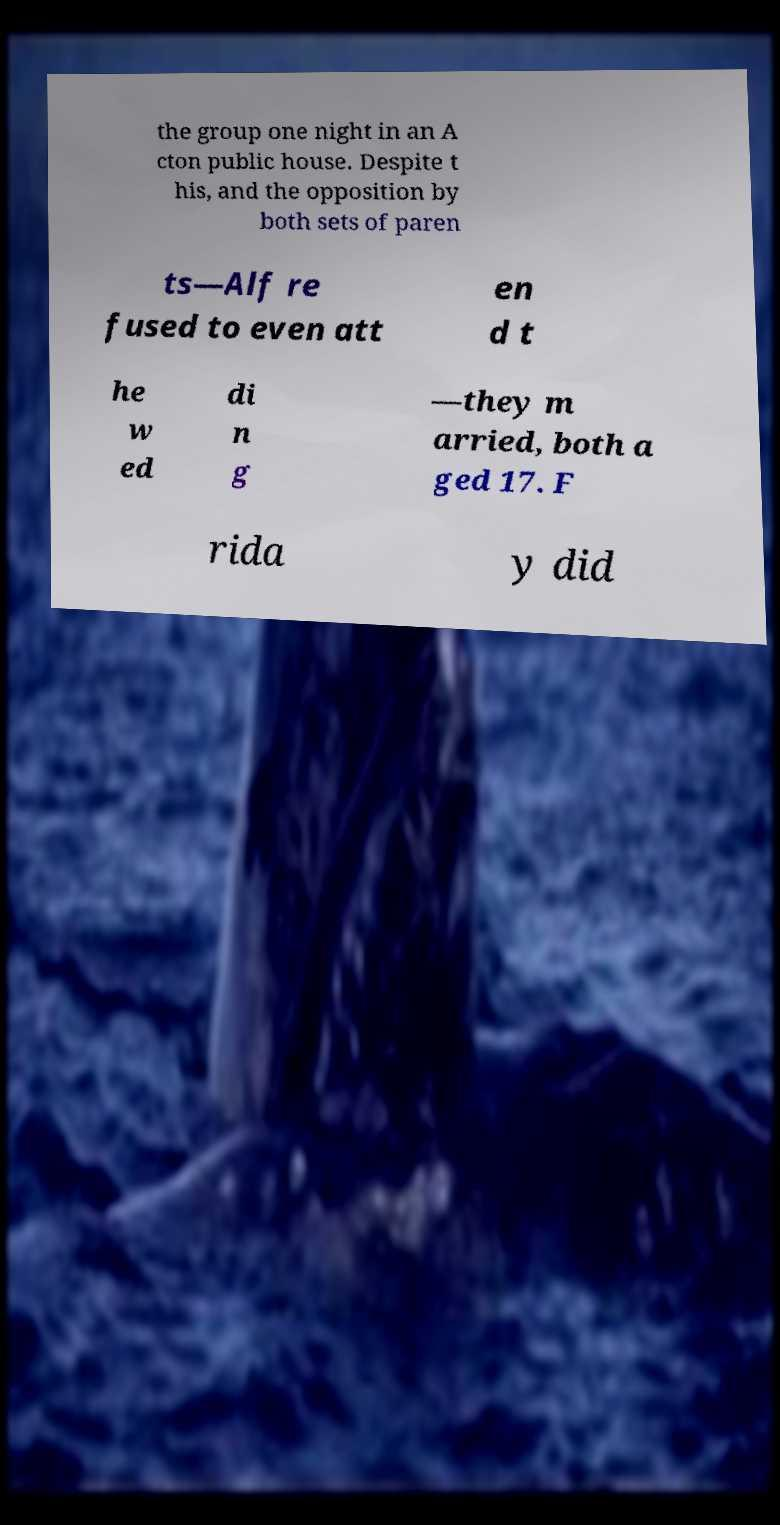Please read and relay the text visible in this image. What does it say? the group one night in an A cton public house. Despite t his, and the opposition by both sets of paren ts—Alf re fused to even att en d t he w ed di n g —they m arried, both a ged 17. F rida y did 